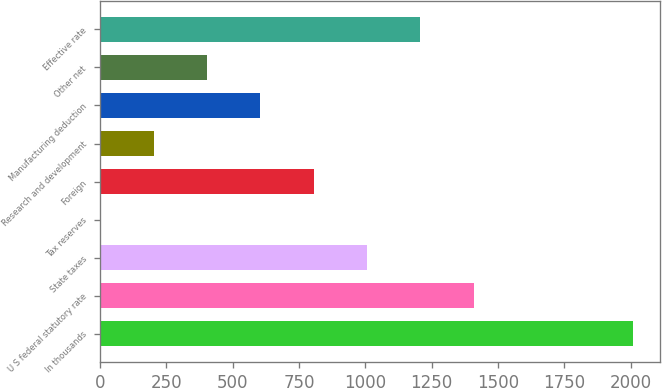Convert chart to OTSL. <chart><loc_0><loc_0><loc_500><loc_500><bar_chart><fcel>In thousands<fcel>U S federal statutory rate<fcel>State taxes<fcel>Tax reserves<fcel>Foreign<fcel>Research and development<fcel>Manufacturing deduction<fcel>Other net<fcel>Effective rate<nl><fcel>2011<fcel>1407.85<fcel>1005.75<fcel>0.5<fcel>804.7<fcel>201.55<fcel>603.65<fcel>402.6<fcel>1206.8<nl></chart> 